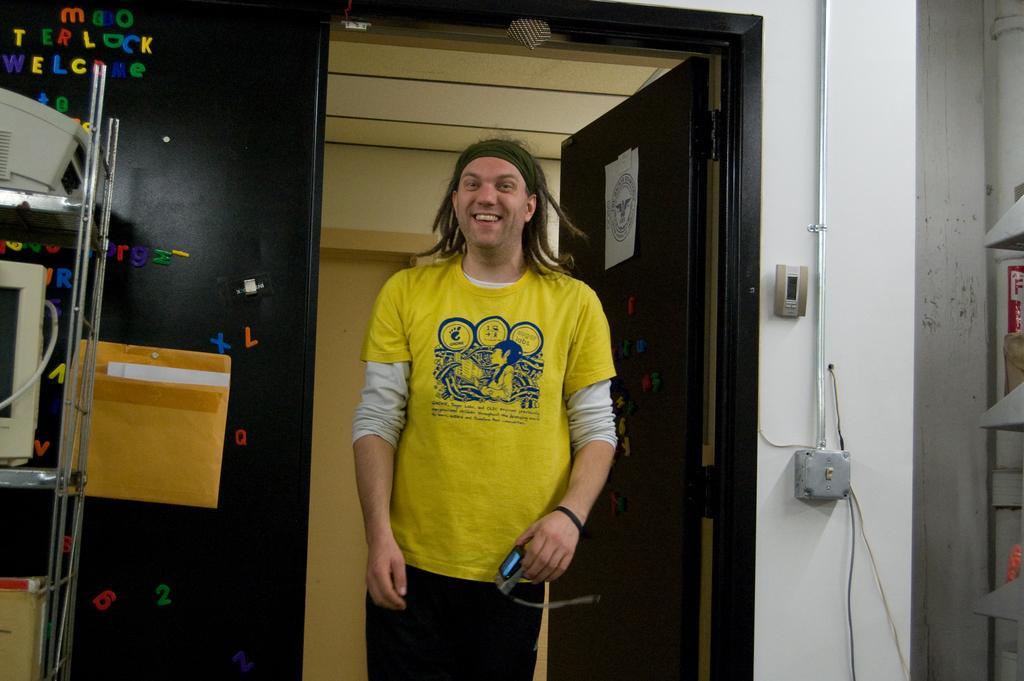Can you describe this image briefly? As we can see in the image there is a wall, door, a person wearing yellow color t shirt, rack, screen and boxes. 